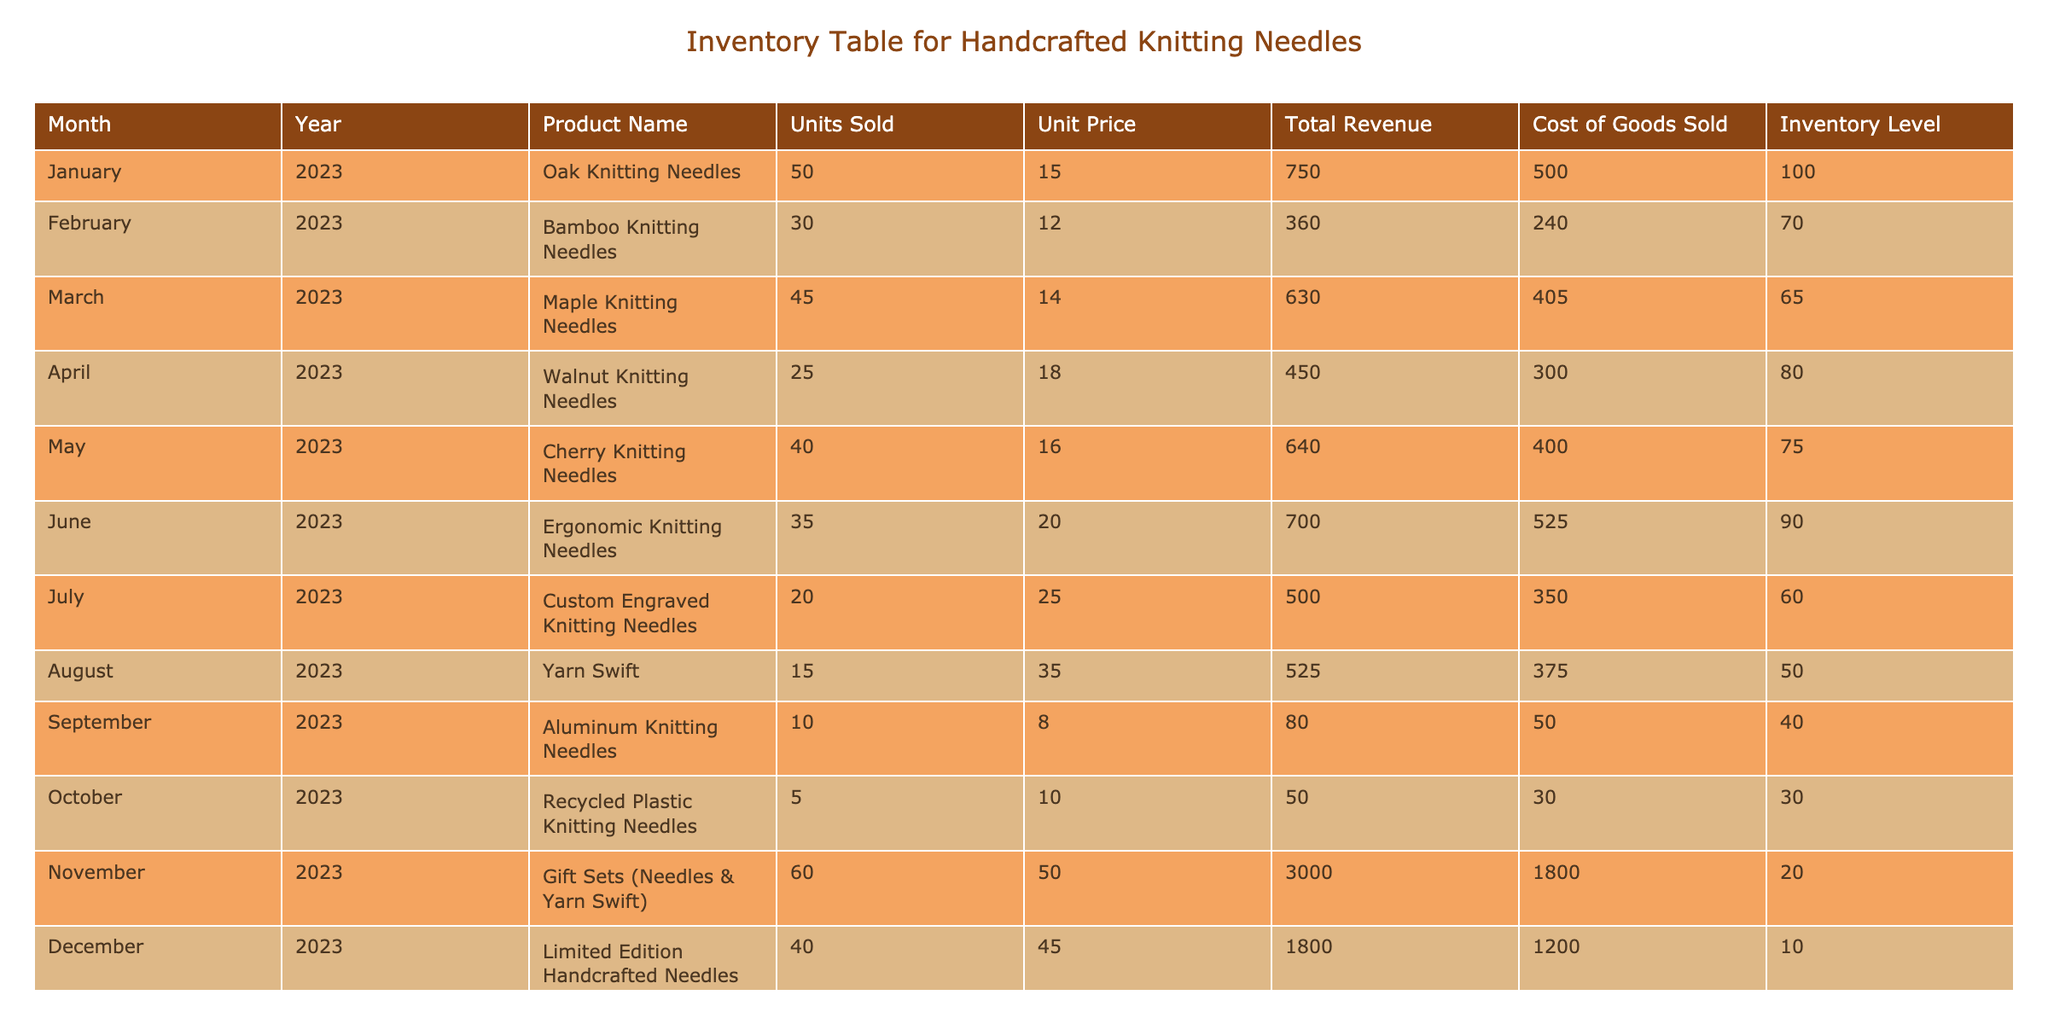What was the total revenue from sales of Walnut Knitting Needles in April 2023? The table lists the total revenue for Walnut Knitting Needles as 450.00 for the month of April 2023.
Answer: 450.00 Which month had the highest total revenue from sales of handcrafted knitting needles? By examining the total revenue column, December 2023 shows a total revenue of 1800.00, which is the highest compared to other months.
Answer: December 2023 What is the average unit price of all the knitting needles sold? The unit prices of the knitting needles are: 15.00, 12.00, 14.00, 18.00, 16.00, 20.00, 25.00, 8.00, 10.00, 45.00. Adding them together gives 15 + 12 + 14 + 18 + 16 + 20 + 25 + 8 + 10 + 45 = 168. There are 10 items, so the average is 168 / 10 = 16.80.
Answer: 16.80 Did the Yarn Swift have a higher unit price than the Recycled Plastic Knitting Needles? The unit price of Yarn Swift is 35.00, while the unit price of Recycled Plastic Knitting Needles is 10.00. Since 35.00 is greater than 10.00, the statement is true.
Answer: Yes What was the total number of units sold for all custom knitting needle products combined in July and December? In July, the units sold for Custom Engraved Knitting Needles is 20, and in December, the units sold for Limited Edition Handcrafted Needles is 40. Adding these gives 20 + 40 = 60 units combined sold in those months.
Answer: 60 Which type of knitting needles had the lowest inventory level, and what was that level? By reviewing the inventory levels, the Limited Edition Handcrafted Needles in December had the lowest inventory level of 10.
Answer: Limited Edition Handcrafted Needles, 10 What is the total revenue generated from all sales of knitting needles in 2023? To find the total revenue for 2023, we sum the total revenues for each month: 750 + 360 + 630 + 450 + 640 + 700 + 500 + 525 + 80 + 50 + 3000 + 1800 = 8335. The total revenue generated from all sales is therefore 8335.
Answer: 8335 Is it true that Cherry Knitting Needles generated more revenue than Bamboo Knitting Needles? Cherry Knitting Needles generated total revenue of 640.00, whereas Bamboo Knitting Needles generated 360.00. Since 640.00 is greater than 360.00, the statement is true.
Answer: Yes 